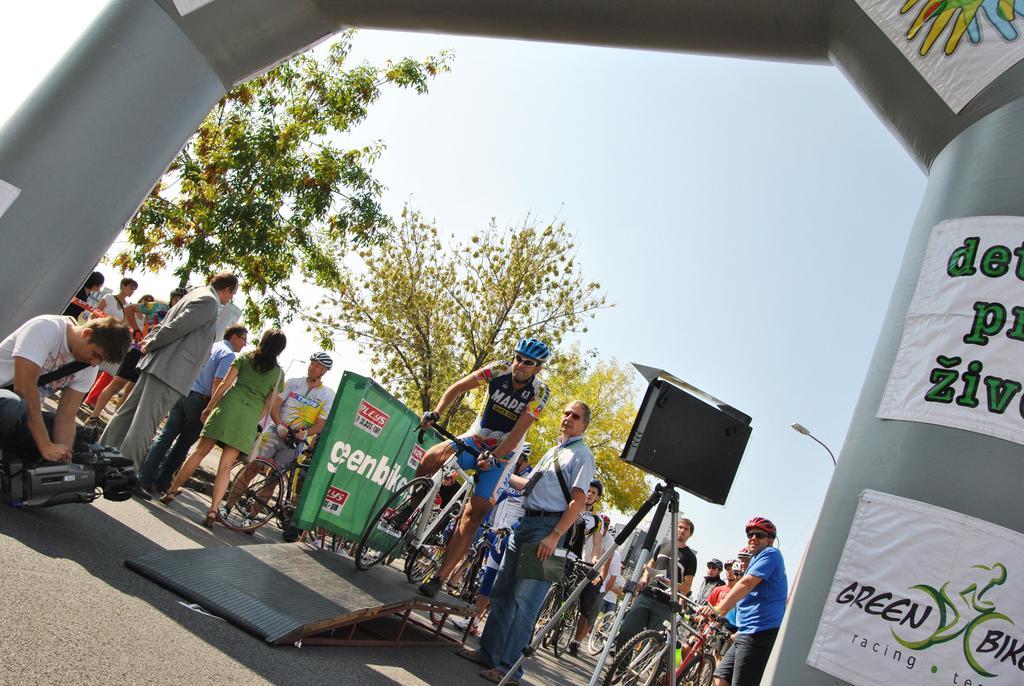In one or two sentences, can you explain what this image depicts? As we can see in the image there is a sky, trees, banner, few people standing and sitting here and there and there are bicycles. 